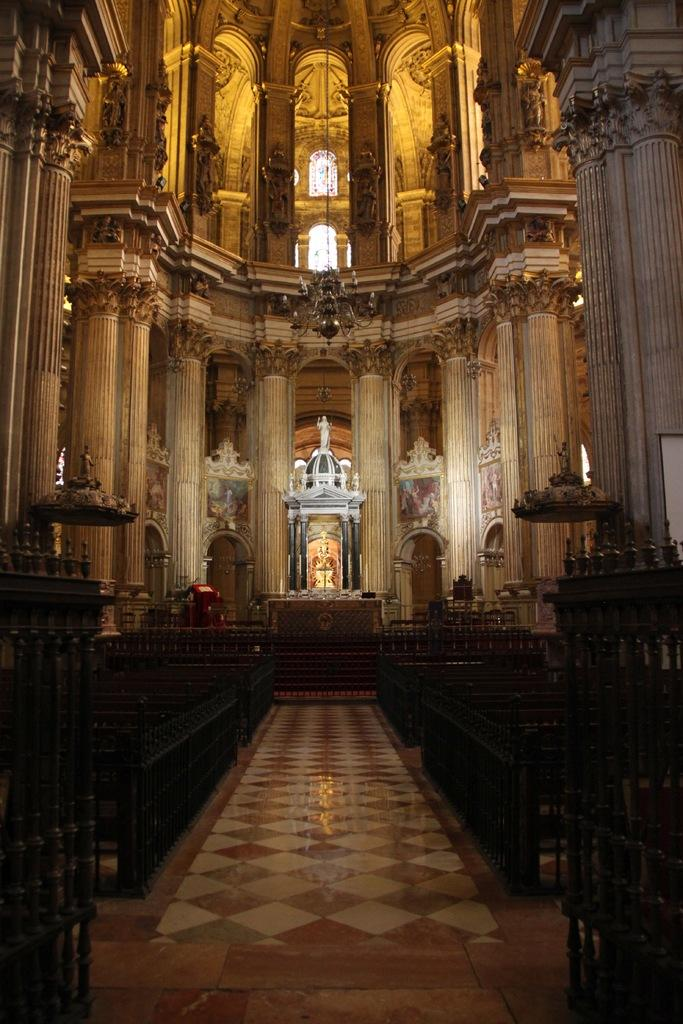What type of structure is visible in the image? There is a building in the image. What is inside the building? The building has a statue in it. What can be seen on either side of the building? There is a fence on either side of the building. What type of finger can be seen holding a drink in the image? There is no finger or drink present in the image; it only features a building with a statue and fences on either side. 